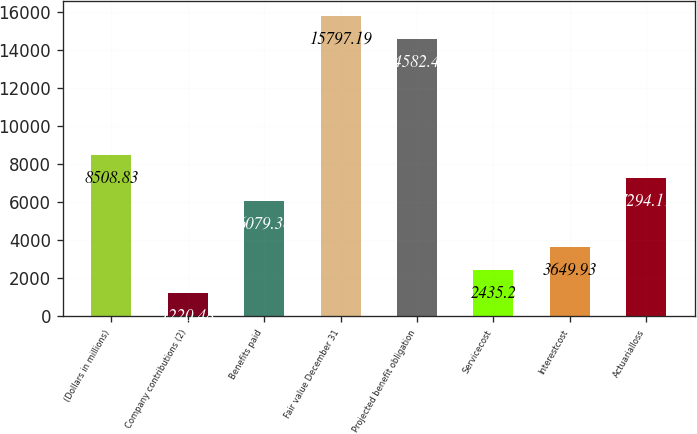Convert chart to OTSL. <chart><loc_0><loc_0><loc_500><loc_500><bar_chart><fcel>(Dollars in millions)<fcel>Company contributions (2)<fcel>Benefits paid<fcel>Fair value December 31<fcel>Projected benefit obligation<fcel>Servicecost<fcel>Interestcost<fcel>Actuarialloss<nl><fcel>8508.83<fcel>1220.48<fcel>6079.38<fcel>15797.2<fcel>14582.5<fcel>2435.2<fcel>3649.93<fcel>7294.11<nl></chart> 